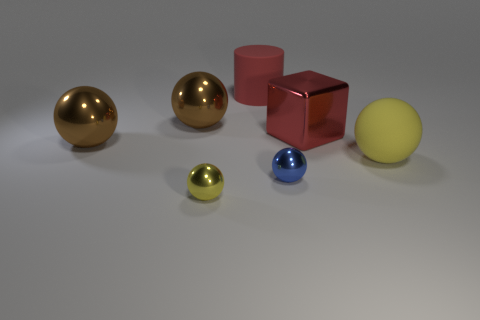How many brown spheres must be subtracted to get 1 brown spheres? 1 Subtract all tiny spheres. How many spheres are left? 3 Add 2 small gray rubber cylinders. How many objects exist? 9 Subtract all blue balls. How many balls are left? 4 Subtract 4 spheres. How many spheres are left? 1 Subtract all yellow blocks. How many yellow spheres are left? 2 Subtract all blocks. How many objects are left? 6 Subtract 0 brown cylinders. How many objects are left? 7 Subtract all blue balls. Subtract all yellow cylinders. How many balls are left? 4 Subtract all large purple rubber balls. Subtract all big red shiny blocks. How many objects are left? 6 